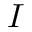<formula> <loc_0><loc_0><loc_500><loc_500>I</formula> 